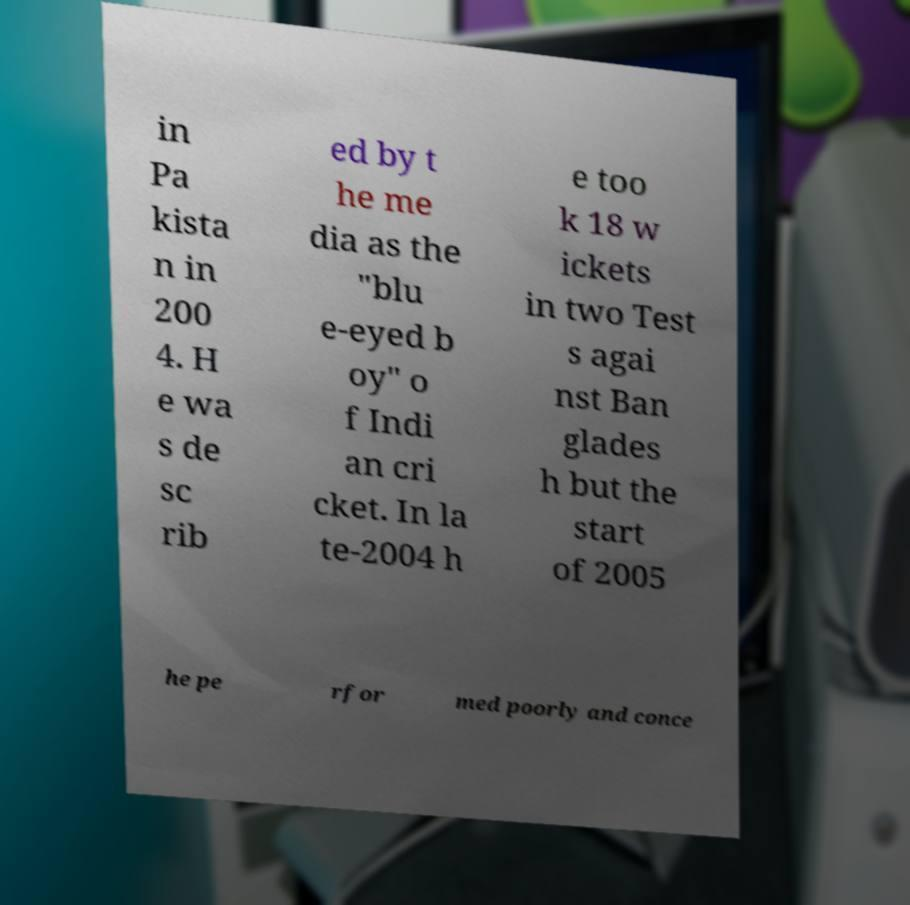Can you read and provide the text displayed in the image?This photo seems to have some interesting text. Can you extract and type it out for me? in Pa kista n in 200 4. H e wa s de sc rib ed by t he me dia as the "blu e-eyed b oy" o f Indi an cri cket. In la te-2004 h e too k 18 w ickets in two Test s agai nst Ban glades h but the start of 2005 he pe rfor med poorly and conce 